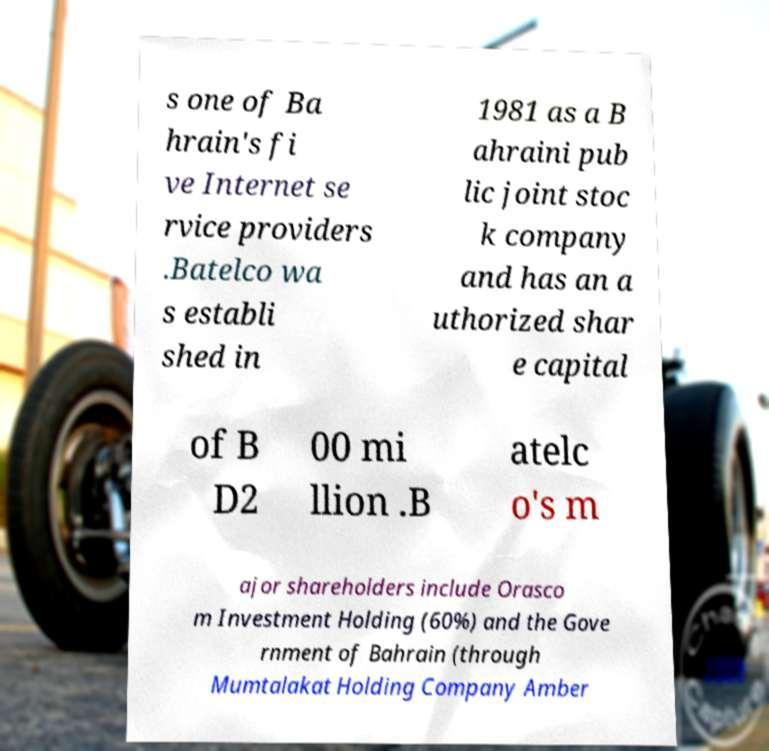For documentation purposes, I need the text within this image transcribed. Could you provide that? s one of Ba hrain's fi ve Internet se rvice providers .Batelco wa s establi shed in 1981 as a B ahraini pub lic joint stoc k company and has an a uthorized shar e capital of B D2 00 mi llion .B atelc o's m ajor shareholders include Orasco m Investment Holding (60%) and the Gove rnment of Bahrain (through Mumtalakat Holding Company Amber 